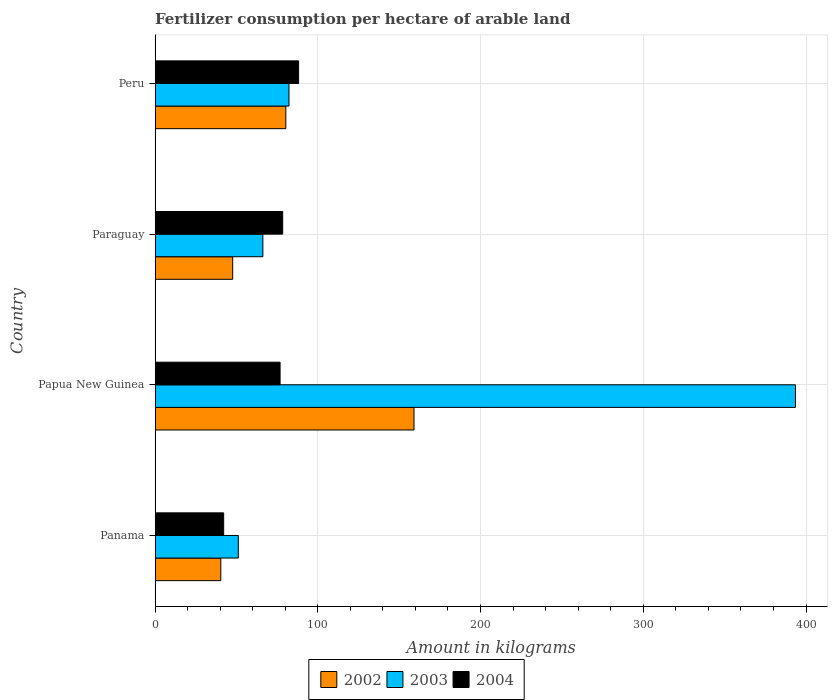How many different coloured bars are there?
Offer a very short reply. 3. Are the number of bars per tick equal to the number of legend labels?
Your answer should be very brief. Yes. How many bars are there on the 1st tick from the bottom?
Offer a terse response. 3. What is the label of the 2nd group of bars from the top?
Offer a very short reply. Paraguay. In how many cases, is the number of bars for a given country not equal to the number of legend labels?
Offer a very short reply. 0. What is the amount of fertilizer consumption in 2003 in Paraguay?
Your answer should be very brief. 66.24. Across all countries, what is the maximum amount of fertilizer consumption in 2002?
Your response must be concise. 159.12. Across all countries, what is the minimum amount of fertilizer consumption in 2003?
Ensure brevity in your answer.  51.16. In which country was the amount of fertilizer consumption in 2004 minimum?
Offer a terse response. Panama. What is the total amount of fertilizer consumption in 2004 in the graph?
Ensure brevity in your answer.  285.62. What is the difference between the amount of fertilizer consumption in 2003 in Panama and that in Papua New Guinea?
Your answer should be compact. -342.37. What is the difference between the amount of fertilizer consumption in 2003 in Panama and the amount of fertilizer consumption in 2002 in Paraguay?
Keep it short and to the point. 3.44. What is the average amount of fertilizer consumption in 2004 per country?
Offer a very short reply. 71.41. What is the difference between the amount of fertilizer consumption in 2002 and amount of fertilizer consumption in 2003 in Paraguay?
Ensure brevity in your answer.  -18.52. What is the ratio of the amount of fertilizer consumption in 2003 in Panama to that in Paraguay?
Provide a succinct answer. 0.77. Is the amount of fertilizer consumption in 2002 in Paraguay less than that in Peru?
Provide a succinct answer. Yes. What is the difference between the highest and the second highest amount of fertilizer consumption in 2004?
Your response must be concise. 9.79. What is the difference between the highest and the lowest amount of fertilizer consumption in 2002?
Provide a short and direct response. 118.71. What does the 3rd bar from the top in Panama represents?
Make the answer very short. 2002. Is it the case that in every country, the sum of the amount of fertilizer consumption in 2004 and amount of fertilizer consumption in 2002 is greater than the amount of fertilizer consumption in 2003?
Your answer should be very brief. No. What is the difference between two consecutive major ticks on the X-axis?
Provide a succinct answer. 100. Are the values on the major ticks of X-axis written in scientific E-notation?
Ensure brevity in your answer.  No. Does the graph contain grids?
Ensure brevity in your answer.  Yes. What is the title of the graph?
Your answer should be compact. Fertilizer consumption per hectare of arable land. Does "1993" appear as one of the legend labels in the graph?
Make the answer very short. No. What is the label or title of the X-axis?
Your answer should be compact. Amount in kilograms. What is the Amount in kilograms of 2002 in Panama?
Your response must be concise. 40.4. What is the Amount in kilograms in 2003 in Panama?
Ensure brevity in your answer.  51.16. What is the Amount in kilograms of 2004 in Panama?
Ensure brevity in your answer.  42.16. What is the Amount in kilograms in 2002 in Papua New Guinea?
Provide a short and direct response. 159.12. What is the Amount in kilograms of 2003 in Papua New Guinea?
Keep it short and to the point. 393.53. What is the Amount in kilograms in 2004 in Papua New Guinea?
Offer a terse response. 76.83. What is the Amount in kilograms in 2002 in Paraguay?
Ensure brevity in your answer.  47.72. What is the Amount in kilograms in 2003 in Paraguay?
Ensure brevity in your answer.  66.24. What is the Amount in kilograms of 2004 in Paraguay?
Provide a succinct answer. 78.42. What is the Amount in kilograms of 2002 in Peru?
Keep it short and to the point. 80.35. What is the Amount in kilograms in 2003 in Peru?
Make the answer very short. 82.3. What is the Amount in kilograms in 2004 in Peru?
Offer a terse response. 88.21. Across all countries, what is the maximum Amount in kilograms in 2002?
Make the answer very short. 159.12. Across all countries, what is the maximum Amount in kilograms in 2003?
Ensure brevity in your answer.  393.53. Across all countries, what is the maximum Amount in kilograms in 2004?
Give a very brief answer. 88.21. Across all countries, what is the minimum Amount in kilograms in 2002?
Offer a very short reply. 40.4. Across all countries, what is the minimum Amount in kilograms of 2003?
Make the answer very short. 51.16. Across all countries, what is the minimum Amount in kilograms of 2004?
Your answer should be compact. 42.16. What is the total Amount in kilograms of 2002 in the graph?
Make the answer very short. 327.59. What is the total Amount in kilograms in 2003 in the graph?
Your answer should be very brief. 593.22. What is the total Amount in kilograms in 2004 in the graph?
Offer a terse response. 285.62. What is the difference between the Amount in kilograms of 2002 in Panama and that in Papua New Guinea?
Offer a very short reply. -118.71. What is the difference between the Amount in kilograms in 2003 in Panama and that in Papua New Guinea?
Provide a succinct answer. -342.37. What is the difference between the Amount in kilograms of 2004 in Panama and that in Papua New Guinea?
Your answer should be very brief. -34.67. What is the difference between the Amount in kilograms of 2002 in Panama and that in Paraguay?
Keep it short and to the point. -7.31. What is the difference between the Amount in kilograms of 2003 in Panama and that in Paraguay?
Offer a terse response. -15.08. What is the difference between the Amount in kilograms of 2004 in Panama and that in Paraguay?
Provide a succinct answer. -36.26. What is the difference between the Amount in kilograms of 2002 in Panama and that in Peru?
Give a very brief answer. -39.95. What is the difference between the Amount in kilograms in 2003 in Panama and that in Peru?
Make the answer very short. -31.14. What is the difference between the Amount in kilograms in 2004 in Panama and that in Peru?
Ensure brevity in your answer.  -46.05. What is the difference between the Amount in kilograms of 2002 in Papua New Guinea and that in Paraguay?
Offer a terse response. 111.4. What is the difference between the Amount in kilograms of 2003 in Papua New Guinea and that in Paraguay?
Your response must be concise. 327.29. What is the difference between the Amount in kilograms in 2004 in Papua New Guinea and that in Paraguay?
Provide a short and direct response. -1.6. What is the difference between the Amount in kilograms of 2002 in Papua New Guinea and that in Peru?
Keep it short and to the point. 78.76. What is the difference between the Amount in kilograms in 2003 in Papua New Guinea and that in Peru?
Your response must be concise. 311.23. What is the difference between the Amount in kilograms of 2004 in Papua New Guinea and that in Peru?
Your answer should be very brief. -11.39. What is the difference between the Amount in kilograms of 2002 in Paraguay and that in Peru?
Offer a terse response. -32.64. What is the difference between the Amount in kilograms of 2003 in Paraguay and that in Peru?
Ensure brevity in your answer.  -16.06. What is the difference between the Amount in kilograms in 2004 in Paraguay and that in Peru?
Your response must be concise. -9.79. What is the difference between the Amount in kilograms of 2002 in Panama and the Amount in kilograms of 2003 in Papua New Guinea?
Offer a terse response. -353.13. What is the difference between the Amount in kilograms in 2002 in Panama and the Amount in kilograms in 2004 in Papua New Guinea?
Provide a succinct answer. -36.42. What is the difference between the Amount in kilograms in 2003 in Panama and the Amount in kilograms in 2004 in Papua New Guinea?
Keep it short and to the point. -25.67. What is the difference between the Amount in kilograms in 2002 in Panama and the Amount in kilograms in 2003 in Paraguay?
Make the answer very short. -25.84. What is the difference between the Amount in kilograms in 2002 in Panama and the Amount in kilograms in 2004 in Paraguay?
Keep it short and to the point. -38.02. What is the difference between the Amount in kilograms in 2003 in Panama and the Amount in kilograms in 2004 in Paraguay?
Your answer should be compact. -27.27. What is the difference between the Amount in kilograms of 2002 in Panama and the Amount in kilograms of 2003 in Peru?
Provide a short and direct response. -41.9. What is the difference between the Amount in kilograms in 2002 in Panama and the Amount in kilograms in 2004 in Peru?
Ensure brevity in your answer.  -47.81. What is the difference between the Amount in kilograms of 2003 in Panama and the Amount in kilograms of 2004 in Peru?
Your response must be concise. -37.05. What is the difference between the Amount in kilograms of 2002 in Papua New Guinea and the Amount in kilograms of 2003 in Paraguay?
Give a very brief answer. 92.88. What is the difference between the Amount in kilograms in 2002 in Papua New Guinea and the Amount in kilograms in 2004 in Paraguay?
Ensure brevity in your answer.  80.7. What is the difference between the Amount in kilograms in 2003 in Papua New Guinea and the Amount in kilograms in 2004 in Paraguay?
Provide a short and direct response. 315.11. What is the difference between the Amount in kilograms in 2002 in Papua New Guinea and the Amount in kilograms in 2003 in Peru?
Your response must be concise. 76.82. What is the difference between the Amount in kilograms in 2002 in Papua New Guinea and the Amount in kilograms in 2004 in Peru?
Ensure brevity in your answer.  70.91. What is the difference between the Amount in kilograms of 2003 in Papua New Guinea and the Amount in kilograms of 2004 in Peru?
Provide a short and direct response. 305.32. What is the difference between the Amount in kilograms of 2002 in Paraguay and the Amount in kilograms of 2003 in Peru?
Provide a succinct answer. -34.58. What is the difference between the Amount in kilograms of 2002 in Paraguay and the Amount in kilograms of 2004 in Peru?
Provide a short and direct response. -40.5. What is the difference between the Amount in kilograms in 2003 in Paraguay and the Amount in kilograms in 2004 in Peru?
Keep it short and to the point. -21.97. What is the average Amount in kilograms in 2002 per country?
Give a very brief answer. 81.9. What is the average Amount in kilograms in 2003 per country?
Offer a terse response. 148.31. What is the average Amount in kilograms of 2004 per country?
Ensure brevity in your answer.  71.41. What is the difference between the Amount in kilograms of 2002 and Amount in kilograms of 2003 in Panama?
Provide a succinct answer. -10.75. What is the difference between the Amount in kilograms in 2002 and Amount in kilograms in 2004 in Panama?
Make the answer very short. -1.76. What is the difference between the Amount in kilograms in 2003 and Amount in kilograms in 2004 in Panama?
Provide a succinct answer. 9. What is the difference between the Amount in kilograms of 2002 and Amount in kilograms of 2003 in Papua New Guinea?
Keep it short and to the point. -234.41. What is the difference between the Amount in kilograms of 2002 and Amount in kilograms of 2004 in Papua New Guinea?
Provide a short and direct response. 82.29. What is the difference between the Amount in kilograms in 2003 and Amount in kilograms in 2004 in Papua New Guinea?
Your answer should be compact. 316.7. What is the difference between the Amount in kilograms of 2002 and Amount in kilograms of 2003 in Paraguay?
Keep it short and to the point. -18.52. What is the difference between the Amount in kilograms in 2002 and Amount in kilograms in 2004 in Paraguay?
Give a very brief answer. -30.71. What is the difference between the Amount in kilograms of 2003 and Amount in kilograms of 2004 in Paraguay?
Provide a succinct answer. -12.18. What is the difference between the Amount in kilograms in 2002 and Amount in kilograms in 2003 in Peru?
Your response must be concise. -1.94. What is the difference between the Amount in kilograms in 2002 and Amount in kilograms in 2004 in Peru?
Your response must be concise. -7.86. What is the difference between the Amount in kilograms in 2003 and Amount in kilograms in 2004 in Peru?
Keep it short and to the point. -5.91. What is the ratio of the Amount in kilograms in 2002 in Panama to that in Papua New Guinea?
Give a very brief answer. 0.25. What is the ratio of the Amount in kilograms in 2003 in Panama to that in Papua New Guinea?
Offer a very short reply. 0.13. What is the ratio of the Amount in kilograms in 2004 in Panama to that in Papua New Guinea?
Keep it short and to the point. 0.55. What is the ratio of the Amount in kilograms in 2002 in Panama to that in Paraguay?
Your response must be concise. 0.85. What is the ratio of the Amount in kilograms in 2003 in Panama to that in Paraguay?
Ensure brevity in your answer.  0.77. What is the ratio of the Amount in kilograms of 2004 in Panama to that in Paraguay?
Offer a terse response. 0.54. What is the ratio of the Amount in kilograms of 2002 in Panama to that in Peru?
Provide a short and direct response. 0.5. What is the ratio of the Amount in kilograms of 2003 in Panama to that in Peru?
Provide a succinct answer. 0.62. What is the ratio of the Amount in kilograms of 2004 in Panama to that in Peru?
Offer a terse response. 0.48. What is the ratio of the Amount in kilograms of 2002 in Papua New Guinea to that in Paraguay?
Your answer should be very brief. 3.33. What is the ratio of the Amount in kilograms of 2003 in Papua New Guinea to that in Paraguay?
Make the answer very short. 5.94. What is the ratio of the Amount in kilograms of 2004 in Papua New Guinea to that in Paraguay?
Provide a succinct answer. 0.98. What is the ratio of the Amount in kilograms of 2002 in Papua New Guinea to that in Peru?
Give a very brief answer. 1.98. What is the ratio of the Amount in kilograms in 2003 in Papua New Guinea to that in Peru?
Keep it short and to the point. 4.78. What is the ratio of the Amount in kilograms of 2004 in Papua New Guinea to that in Peru?
Make the answer very short. 0.87. What is the ratio of the Amount in kilograms in 2002 in Paraguay to that in Peru?
Offer a terse response. 0.59. What is the ratio of the Amount in kilograms of 2003 in Paraguay to that in Peru?
Provide a succinct answer. 0.8. What is the ratio of the Amount in kilograms in 2004 in Paraguay to that in Peru?
Keep it short and to the point. 0.89. What is the difference between the highest and the second highest Amount in kilograms of 2002?
Make the answer very short. 78.76. What is the difference between the highest and the second highest Amount in kilograms in 2003?
Give a very brief answer. 311.23. What is the difference between the highest and the second highest Amount in kilograms in 2004?
Your response must be concise. 9.79. What is the difference between the highest and the lowest Amount in kilograms of 2002?
Keep it short and to the point. 118.71. What is the difference between the highest and the lowest Amount in kilograms in 2003?
Give a very brief answer. 342.37. What is the difference between the highest and the lowest Amount in kilograms in 2004?
Offer a terse response. 46.05. 